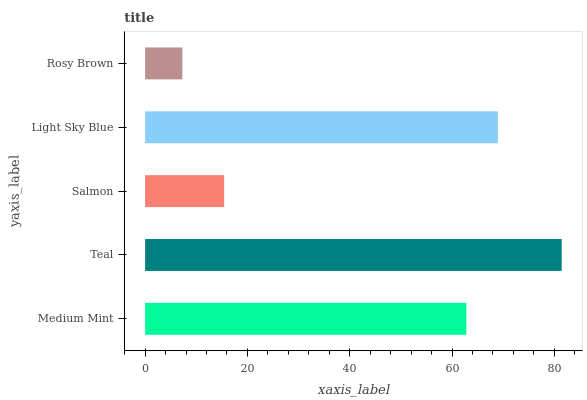Is Rosy Brown the minimum?
Answer yes or no. Yes. Is Teal the maximum?
Answer yes or no. Yes. Is Salmon the minimum?
Answer yes or no. No. Is Salmon the maximum?
Answer yes or no. No. Is Teal greater than Salmon?
Answer yes or no. Yes. Is Salmon less than Teal?
Answer yes or no. Yes. Is Salmon greater than Teal?
Answer yes or no. No. Is Teal less than Salmon?
Answer yes or no. No. Is Medium Mint the high median?
Answer yes or no. Yes. Is Medium Mint the low median?
Answer yes or no. Yes. Is Light Sky Blue the high median?
Answer yes or no. No. Is Rosy Brown the low median?
Answer yes or no. No. 